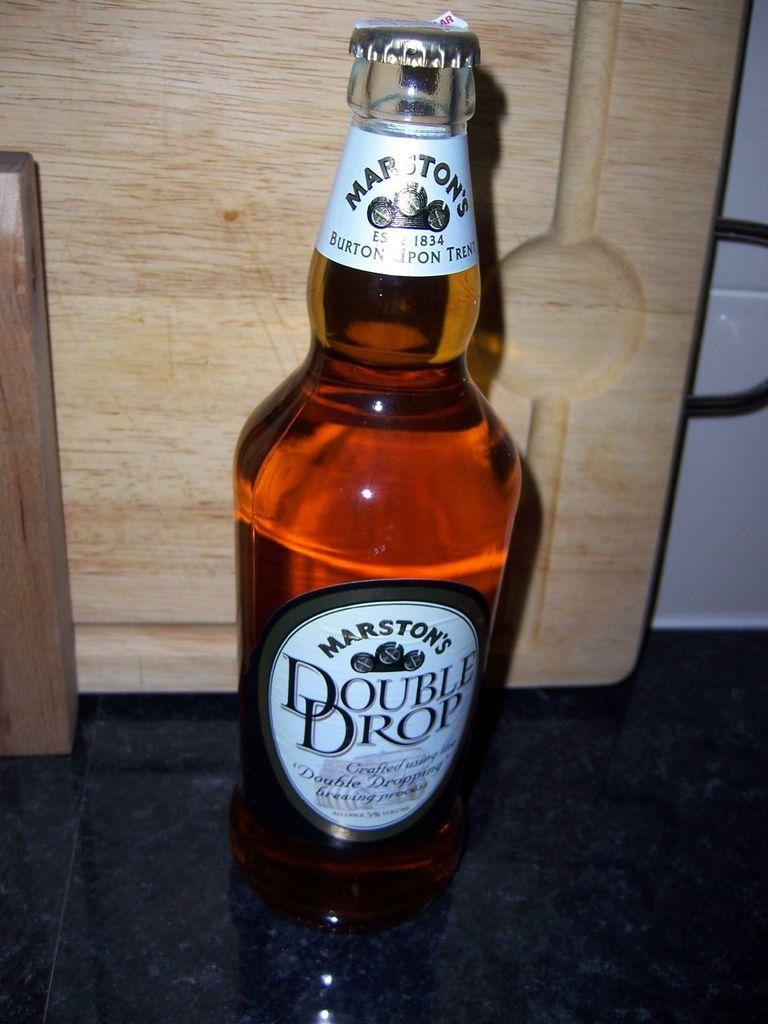Provide a one-sentence caption for the provided image. A bottle of Double Drop sits next to a wooden cutting board. 